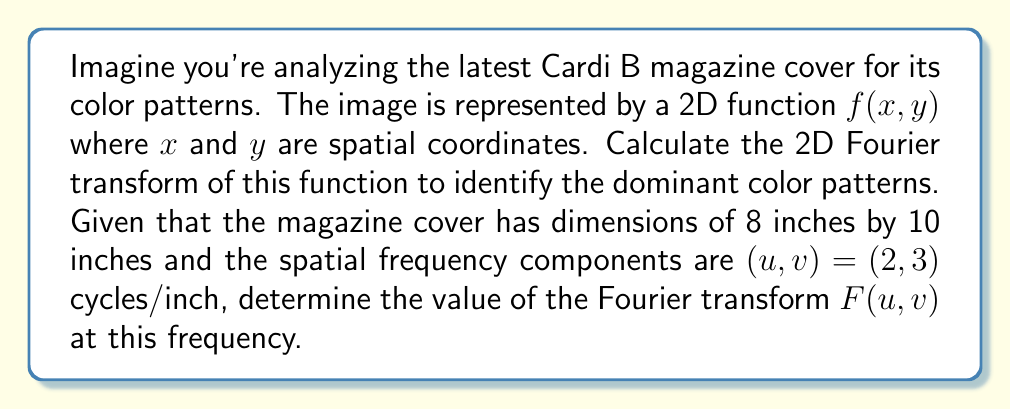Solve this math problem. To solve this problem, we need to apply the 2D Fourier transform to the image function $f(x,y)$. The 2D Fourier transform is given by:

$$F(u,v) = \int_{-\infty}^{\infty}\int_{-\infty}^{\infty} f(x,y) e^{-j2\pi(ux+vy)} dx dy$$

Where:
- $F(u,v)$ is the Fourier transform
- $f(x,y)$ is the original image function
- $u$ and $v$ are spatial frequencies in cycles/inch
- $x$ and $y$ are spatial coordinates in inches

Given:
- Image dimensions: 8 inches by 10 inches
- Spatial frequency components: $(u,v) = (2,3)$ cycles/inch

To calculate $F(2,3)$, we need to evaluate:

$$F(2,3) = \int_{0}^{10}\int_{0}^{8} f(x,y) e^{-j2\pi(2x+3y)} dx dy$$

Since we don't have the exact function $f(x,y)$ for Cardi B's magazine cover, we can't evaluate this integral precisely. However, the magnitude of $F(2,3)$ would represent the strength of the color pattern at 2 cycles/inch horizontally and 3 cycles/inch vertically.

In practice, for a digital image, we would use the Discrete Fourier Transform (DFT) or Fast Fourier Transform (FFT) algorithm to compute this. The result would be a complex number, where the magnitude represents the strength of the frequency component, and the phase represents its spatial offset.

To interpret the result:
1. A large magnitude of $F(2,3)$ would indicate a strong presence of color patterns repeating every 1/2 inch horizontally and 1/3 inch vertically.
2. This could correspond to repeated elements in Cardi B's outfit, background patterns, or text layout on the magazine cover.
3. By analyzing different frequency components, we can identify dominant color patterns at various scales.
Answer: The Fourier transform $F(2,3)$ cannot be explicitly calculated without the specific image function $f(x,y)$. However, its magnitude $|F(2,3)|$ represents the strength of color patterns repeating every 1/2 inch horizontally and 1/3 inch vertically on Cardi B's magazine cover. 